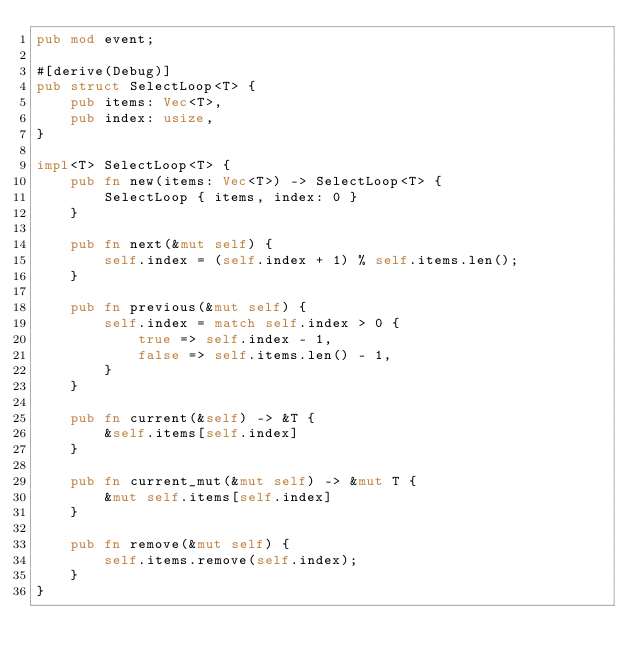<code> <loc_0><loc_0><loc_500><loc_500><_Rust_>pub mod event;

#[derive(Debug)]
pub struct SelectLoop<T> {
    pub items: Vec<T>,
    pub index: usize,
}

impl<T> SelectLoop<T> {
    pub fn new(items: Vec<T>) -> SelectLoop<T> {
        SelectLoop { items, index: 0 }
    }

    pub fn next(&mut self) {
        self.index = (self.index + 1) % self.items.len();
    }

    pub fn previous(&mut self) {
        self.index = match self.index > 0 {
            true => self.index - 1,
            false => self.items.len() - 1,
        }
    }

    pub fn current(&self) -> &T {
        &self.items[self.index]
    }

    pub fn current_mut(&mut self) -> &mut T {
        &mut self.items[self.index]
    }

    pub fn remove(&mut self) {
        self.items.remove(self.index);
    }
}
</code> 